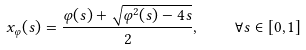<formula> <loc_0><loc_0><loc_500><loc_500>x _ { \varphi } ( s ) = \frac { \varphi ( s ) + \sqrt { \varphi ^ { 2 } ( s ) - 4 s } } { 2 } , \quad \forall s \in [ 0 , 1 ]</formula> 